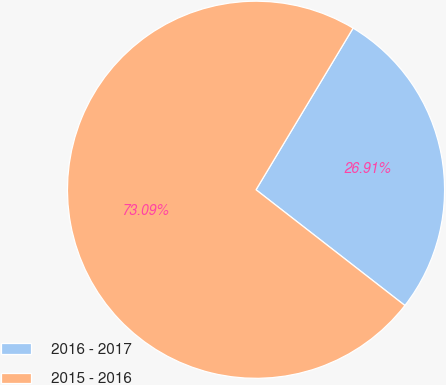<chart> <loc_0><loc_0><loc_500><loc_500><pie_chart><fcel>2016 - 2017<fcel>2015 - 2016<nl><fcel>26.91%<fcel>73.09%<nl></chart> 